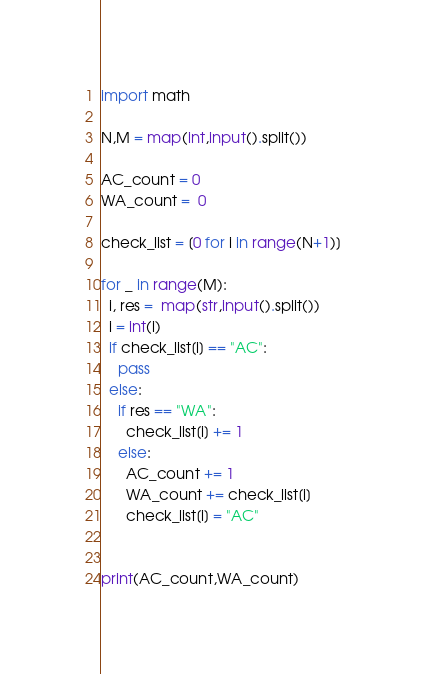<code> <loc_0><loc_0><loc_500><loc_500><_Python_>import math

N,M = map(int,input().split())

AC_count = 0
WA_count =  0

check_list = [0 for i in range(N+1)]

for _ in range(M):
  i, res =  map(str,input().split())
  i = int(i)
  if check_list[i] == "AC":
    pass
  else:
    if res == "WA":
      check_list[i] += 1
    else:
      AC_count += 1
      WA_count += check_list[i]
      check_list[i] = "AC"
    
  
print(AC_count,WA_count)</code> 